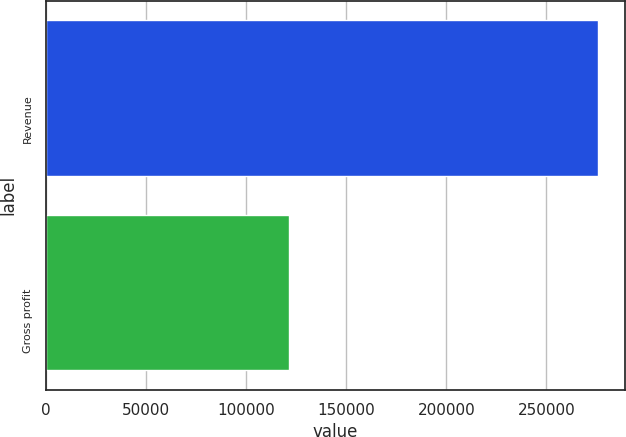<chart> <loc_0><loc_0><loc_500><loc_500><bar_chart><fcel>Revenue<fcel>Gross profit<nl><fcel>275502<fcel>121328<nl></chart> 